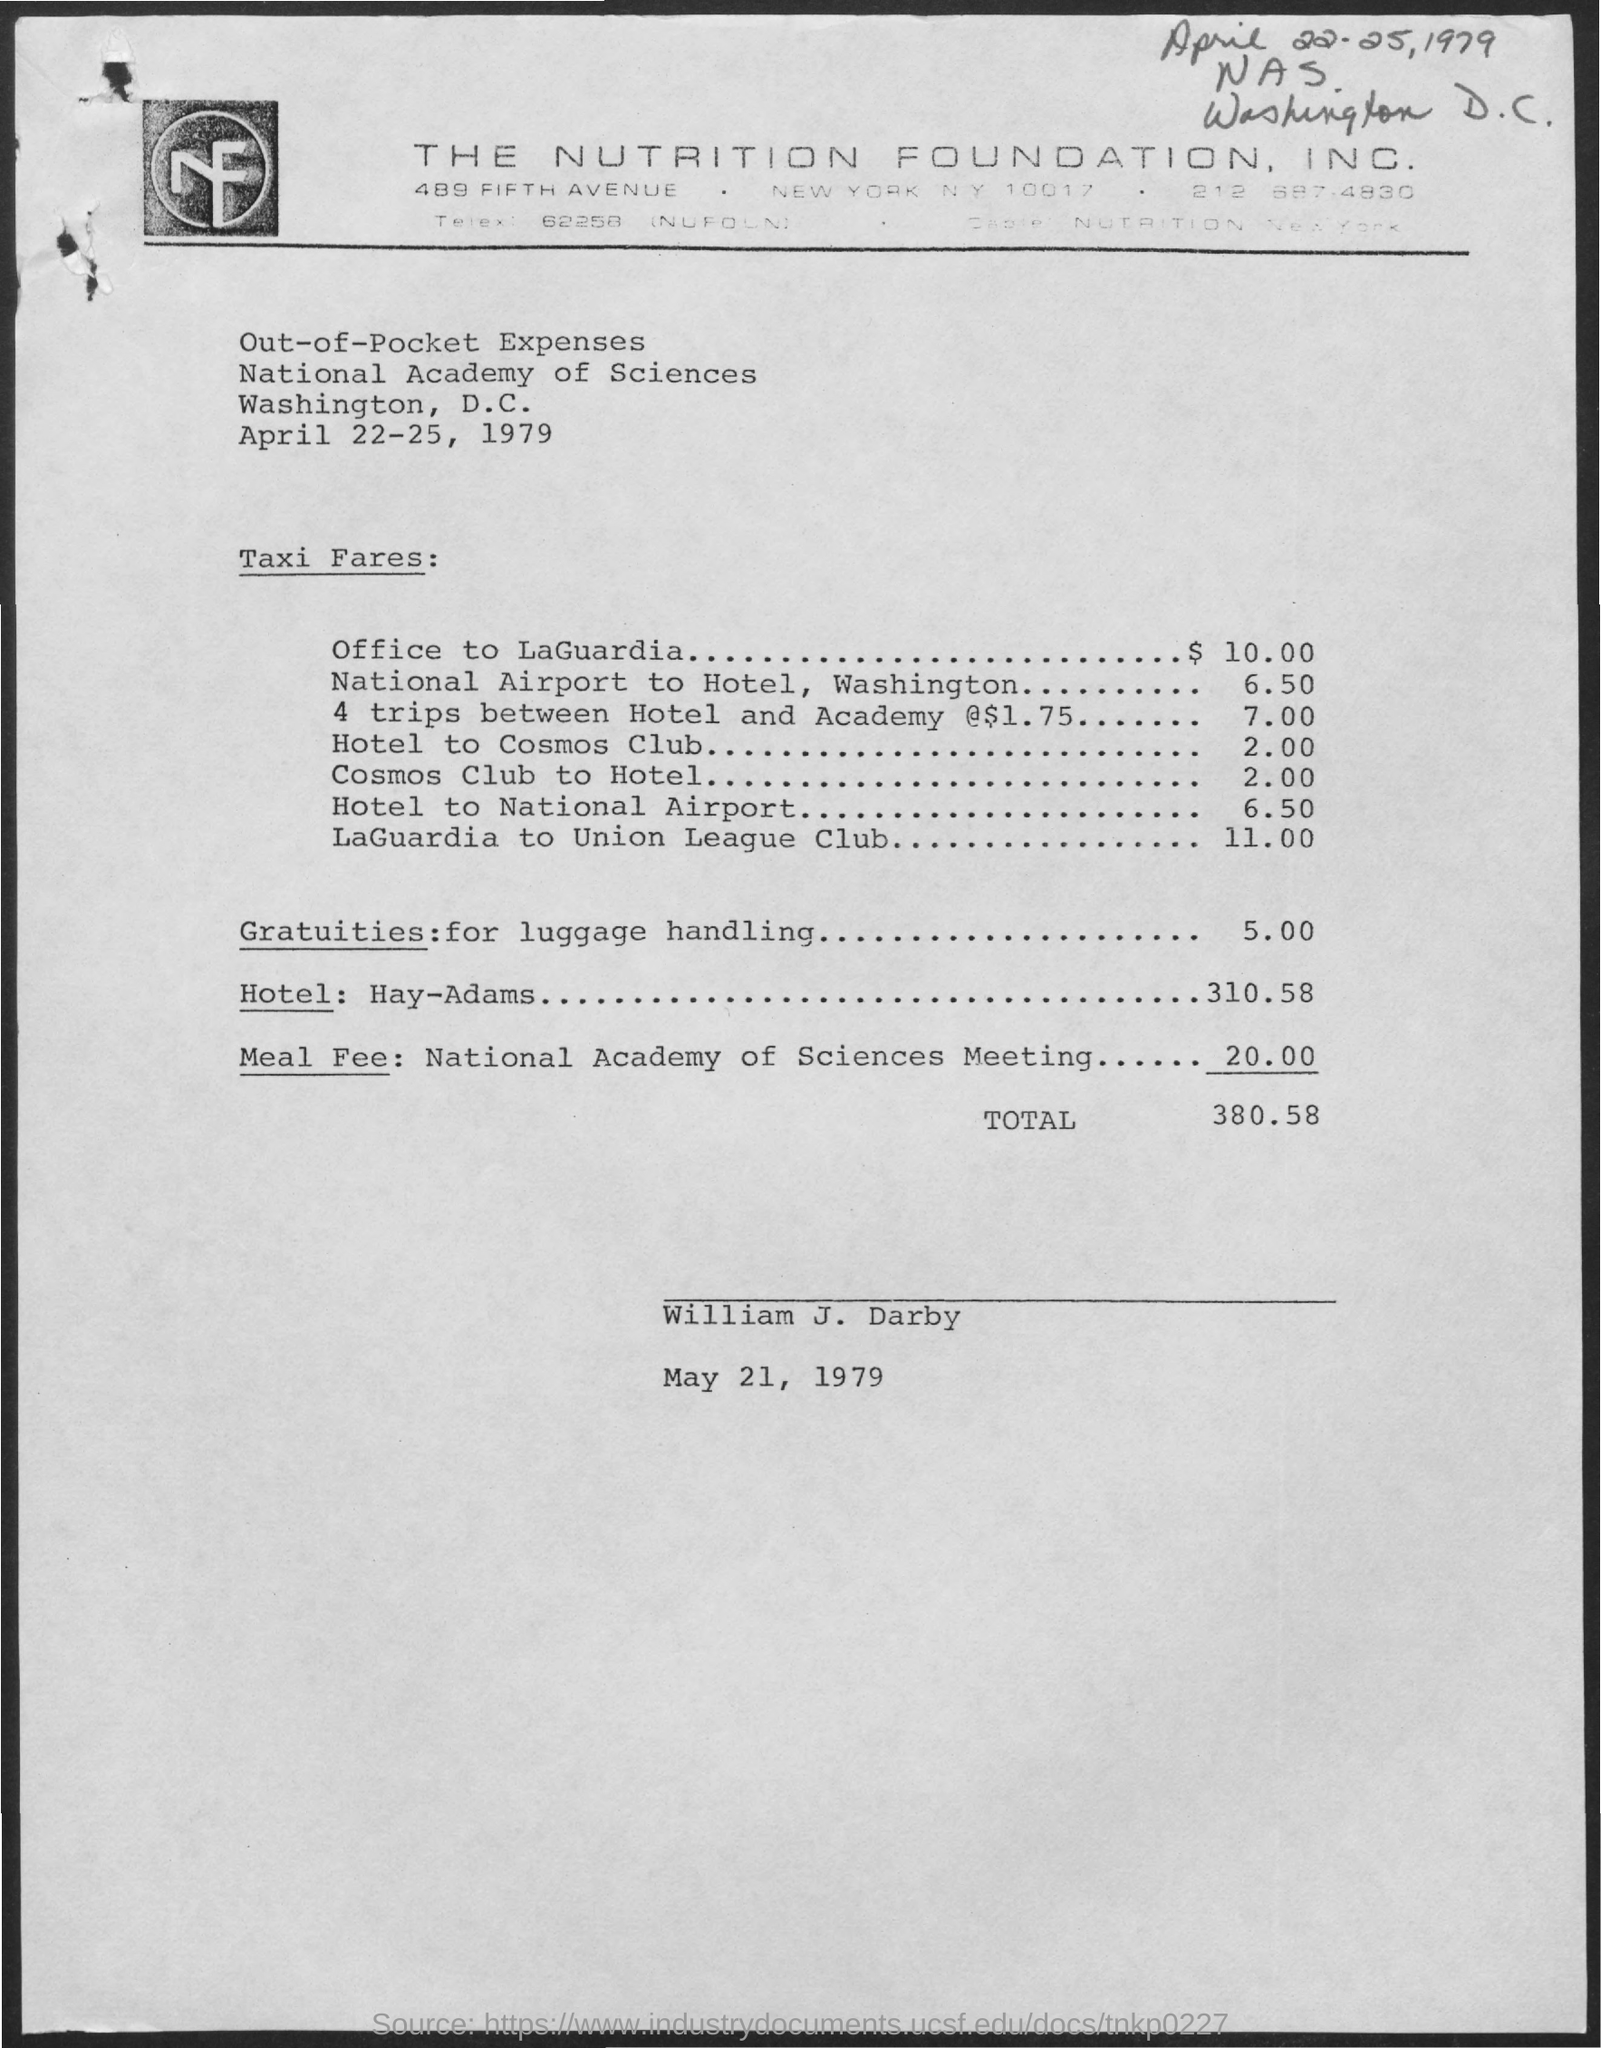Mention a couple of crucial points in this snapshot. The taxi fare from Office to LaGuardia is $10.00. The total expense is 380 and 58 dollars and cents. The gratuities for luggage handling are $5.00. The date written at the top of the page is April 22-25, 1979. 